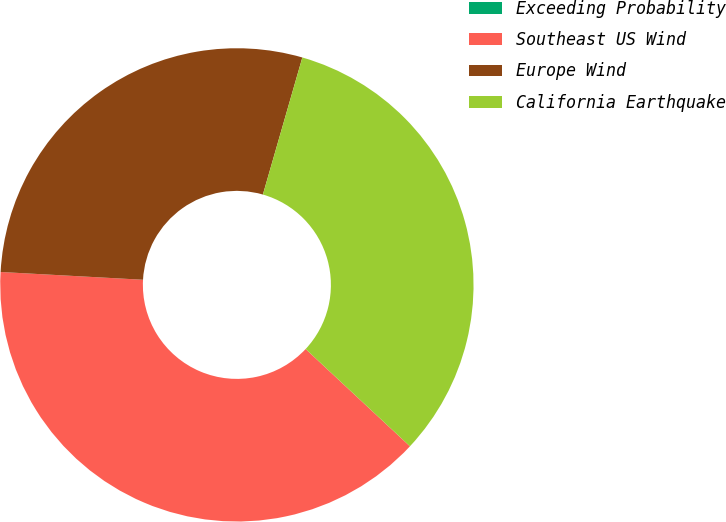<chart> <loc_0><loc_0><loc_500><loc_500><pie_chart><fcel>Exceeding Probability<fcel>Southeast US Wind<fcel>Europe Wind<fcel>California Earthquake<nl><fcel>0.0%<fcel>38.92%<fcel>28.59%<fcel>32.48%<nl></chart> 